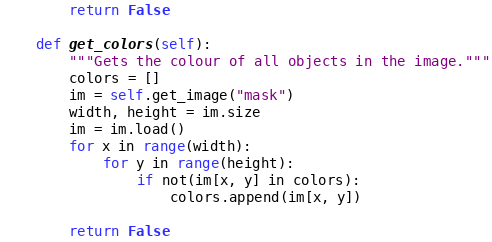Convert code to text. <code><loc_0><loc_0><loc_500><loc_500><_Python_>        return False

    def get_colors(self):
        """Gets the colour of all objects in the image."""
        colors = []
        im = self.get_image("mask")
        width, height = im.size
        im = im.load()
        for x in range(width):
            for y in range(height):
                if not(im[x, y] in colors):
                    colors.append(im[x, y])

        return False

</code> 